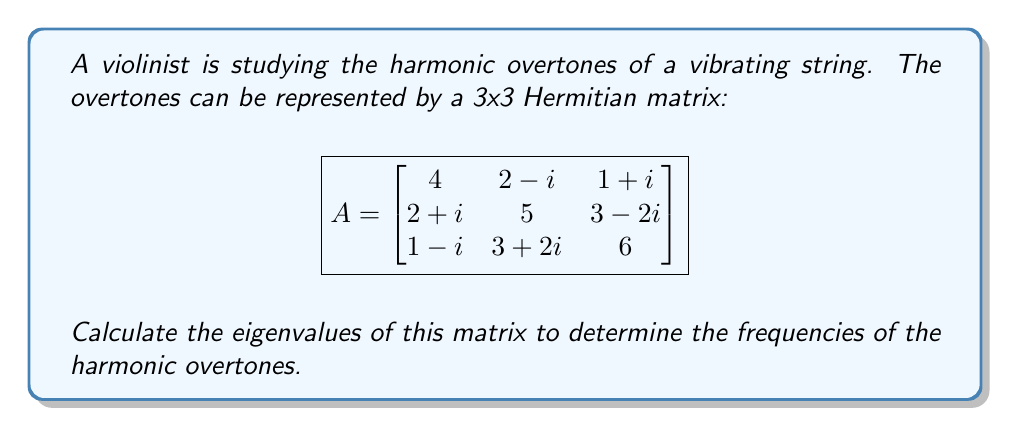What is the answer to this math problem? To find the eigenvalues of the Hermitian matrix A, we need to solve the characteristic equation:

$$det(A - \lambda I) = 0$$

where $\lambda$ represents the eigenvalues and $I$ is the 3x3 identity matrix.

Step 1: Expand the determinant:
$$\begin{vmatrix}
4-\lambda & 2-i & 1+i \\
2+i & 5-\lambda & 3-2i \\
1-i & 3+2i & 6-\lambda
\end{vmatrix} = 0$$

Step 2: Calculate the determinant:
$$(4-\lambda)(5-\lambda)(6-\lambda) + (2-i)(3-2i)(1-i) + (1+i)(2+i)(3+2i) - (1+i)(5-\lambda)(1-i) - (4-\lambda)(3-2i)(3+2i) - (2-i)(2+i)(6-\lambda) = 0$$

Step 3: Simplify the equation:
$$-\lambda^3 + 15\lambda^2 - 74\lambda + 120 + 14 + 14 - (2)(15-\lambda) - (4-\lambda)(17) - (5)(6-\lambda) = 0$$

Step 4: Combine like terms:
$$-\lambda^3 + 15\lambda^2 - 74\lambda + 148 - 30 + 2\lambda - 68 + 17\lambda - 30 + 5\lambda = 0$$

Step 5: Simplify further:
$$-\lambda^3 + 15\lambda^2 - 50\lambda + 20 = 0$$

Step 6: Factor the equation:
$$-(\lambda - 2)(\lambda - 5)(\lambda - 8) = 0$$

Step 7: Solve for $\lambda$:
$$\lambda = 2, 5, \text{ or } 8$$

These are the eigenvalues of the matrix A, representing the frequencies of the harmonic overtones.
Answer: $\lambda = 2, 5, 8$ 